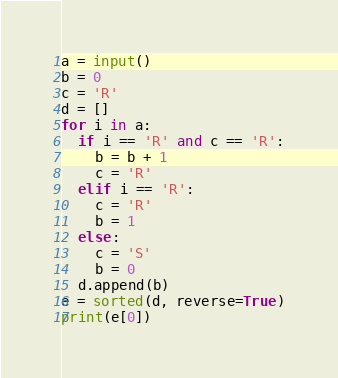Convert code to text. <code><loc_0><loc_0><loc_500><loc_500><_Python_>a = input()
b = 0
c = 'R'
d = []
for i in a:
  if i == 'R' and c == 'R':
    b = b + 1
    c = 'R'
  elif i == 'R':
    c = 'R'
    b = 1
  else:
    c = 'S'
    b = 0
  d.append(b)
e = sorted(d, reverse=True)
print(e[0])</code> 